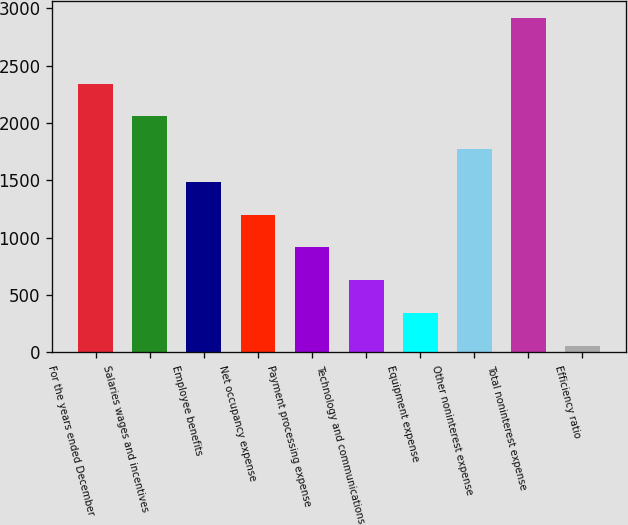<chart> <loc_0><loc_0><loc_500><loc_500><bar_chart><fcel>For the years ended December<fcel>Salaries wages and incentives<fcel>Employee benefits<fcel>Net occupancy expense<fcel>Payment processing expense<fcel>Technology and communications<fcel>Equipment expense<fcel>Other noninterest expense<fcel>Total noninterest expense<fcel>Efficiency ratio<nl><fcel>2343.88<fcel>2058.32<fcel>1487.2<fcel>1201.64<fcel>916.08<fcel>630.52<fcel>344.96<fcel>1772.76<fcel>2915<fcel>59.4<nl></chart> 